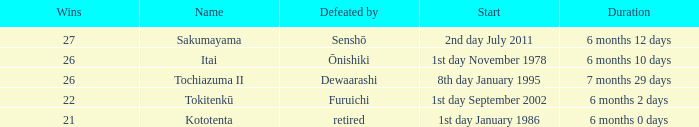Which Start has a Duration of 6 months 2 days? 1st day September 2002. 